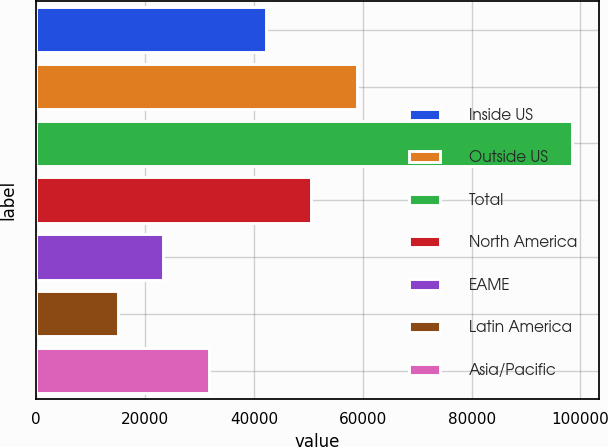<chart> <loc_0><loc_0><loc_500><loc_500><bar_chart><fcel>Inside US<fcel>Outside US<fcel>Total<fcel>North America<fcel>EAME<fcel>Latin America<fcel>Asia/Pacific<nl><fcel>42200<fcel>58880<fcel>98400<fcel>50540<fcel>23340<fcel>15000<fcel>31680<nl></chart> 